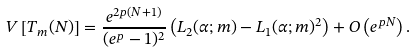<formula> <loc_0><loc_0><loc_500><loc_500>V \left [ T _ { m } ( N ) \right ] = \frac { e ^ { 2 p ( N + 1 ) } } { ( e ^ { p } - 1 ) ^ { 2 } } \left ( L _ { 2 } ( \alpha ; m ) - L _ { 1 } ( \alpha ; m ) ^ { 2 } \right ) + O \left ( e ^ { p N } \right ) .</formula> 